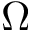Convert formula to latex. <formula><loc_0><loc_0><loc_500><loc_500>\Omega</formula> 